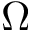Convert formula to latex. <formula><loc_0><loc_0><loc_500><loc_500>\Omega</formula> 